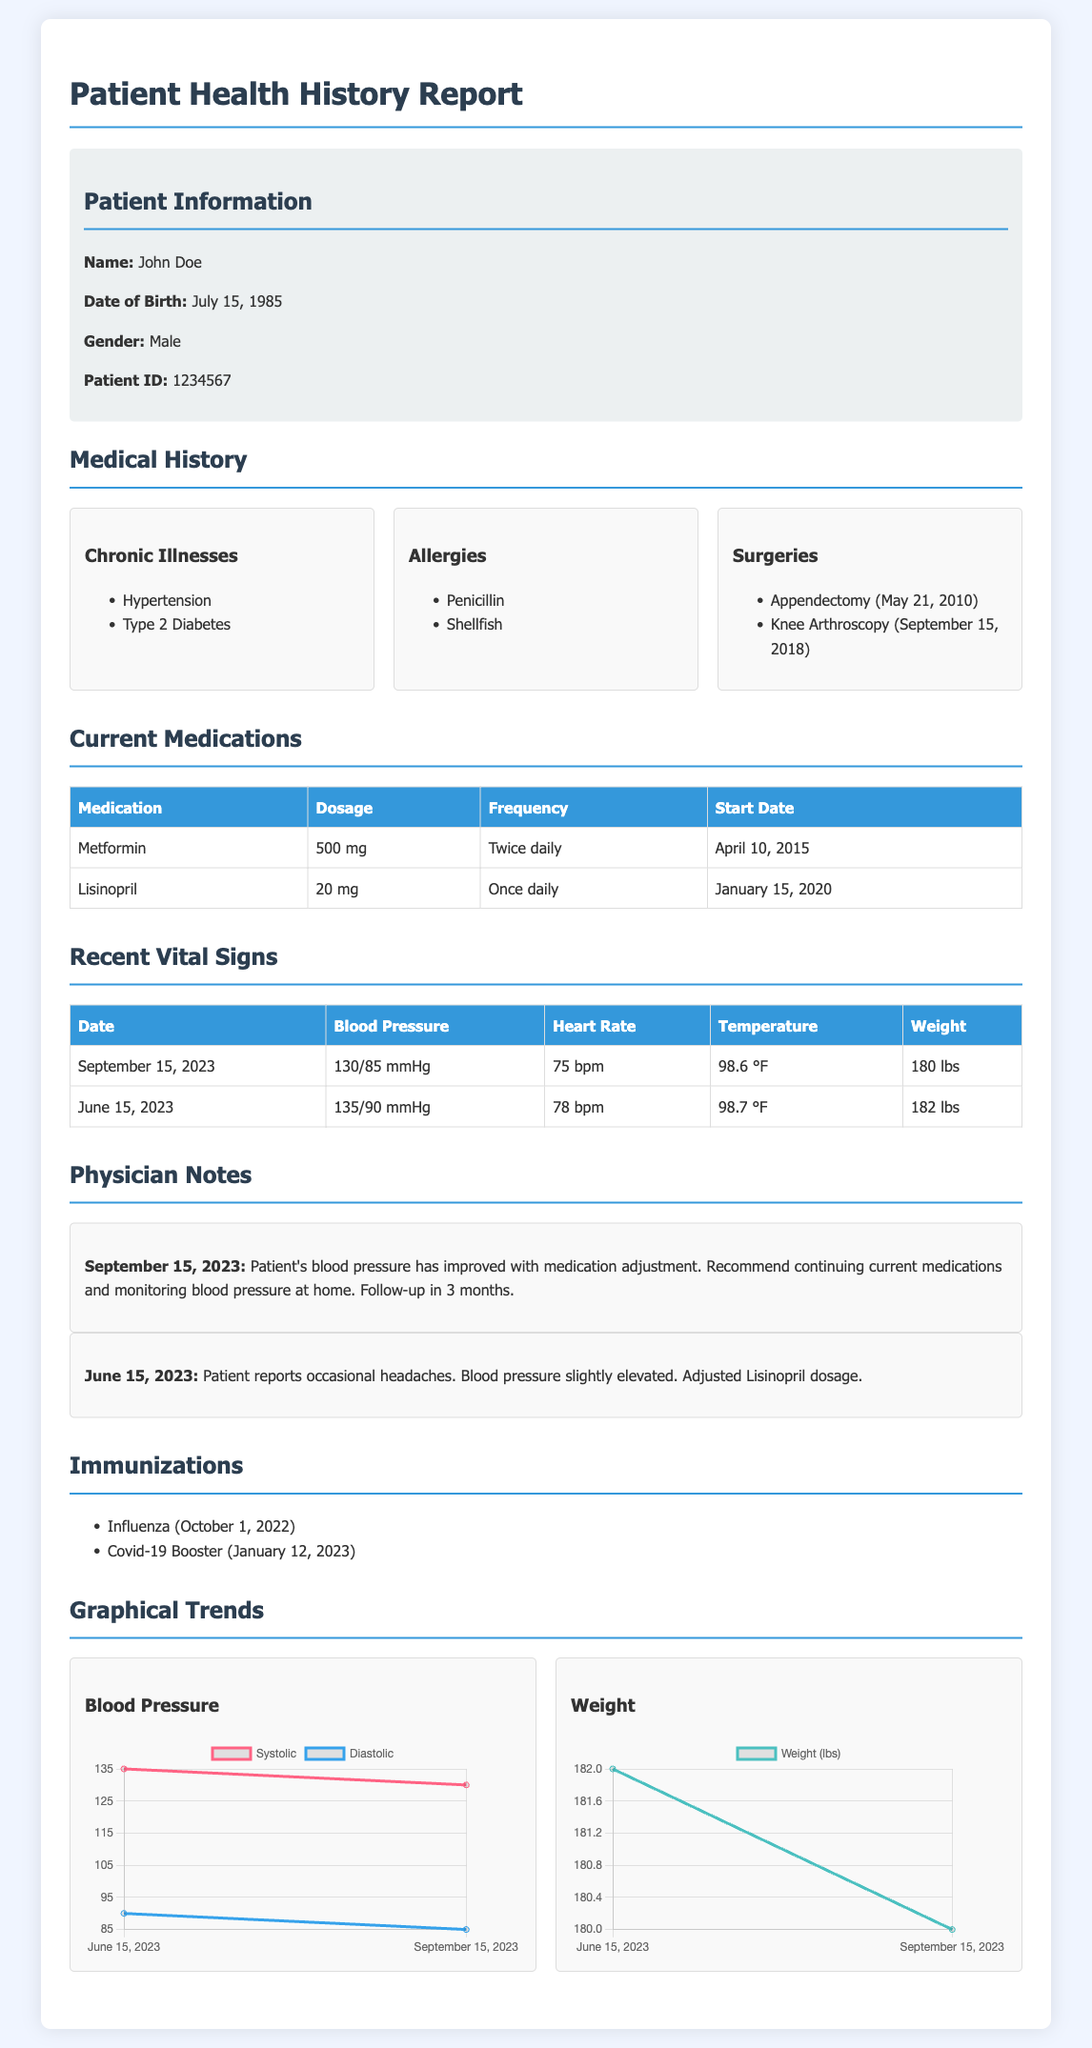What chronic illnesses does the patient have? The chronic illnesses listed in the document are Hypertension and Type 2 Diabetes.
Answer: Hypertension, Type 2 Diabetes What medications is the patient currently taking? The medications listed in the document are Metformin and Lisinopril.
Answer: Metformin, Lisinopril What was the patient's weight on June 15, 2023? The document provides the patient's weight as 182 lbs on June 15, 2023.
Answer: 182 lbs When did the patient have their last appendectomy? The document states that the patient had an appendectomy on May 21, 2010.
Answer: May 21, 2010 What is the patient's systolic blood pressure on September 15, 2023? The document lists the systolic blood pressure as 130 mmHg on September 15, 2023.
Answer: 130 mmHg What allergy does the patient have? The allergies mentioned in the document include Penicillin and Shellfish.
Answer: Penicillin, Shellfish What are the dates of the patient's recent vital signs? The dates mentioned for the recent vital signs are June 15, 2023, and September 15, 2023.
Answer: June 15, 2023, September 15, 2023 What type of medical report is this document? The document is a Patient Health History Report, which details medical history, medications, and vital signs.
Answer: Patient Health History Report What is the physician's note recommendation from September 15, 2023? The physician's note suggests to continue current medications and monitor blood pressure at home with a follow-up in 3 months.
Answer: Continue current medications, monitor blood pressure at home, follow-up in 3 months 